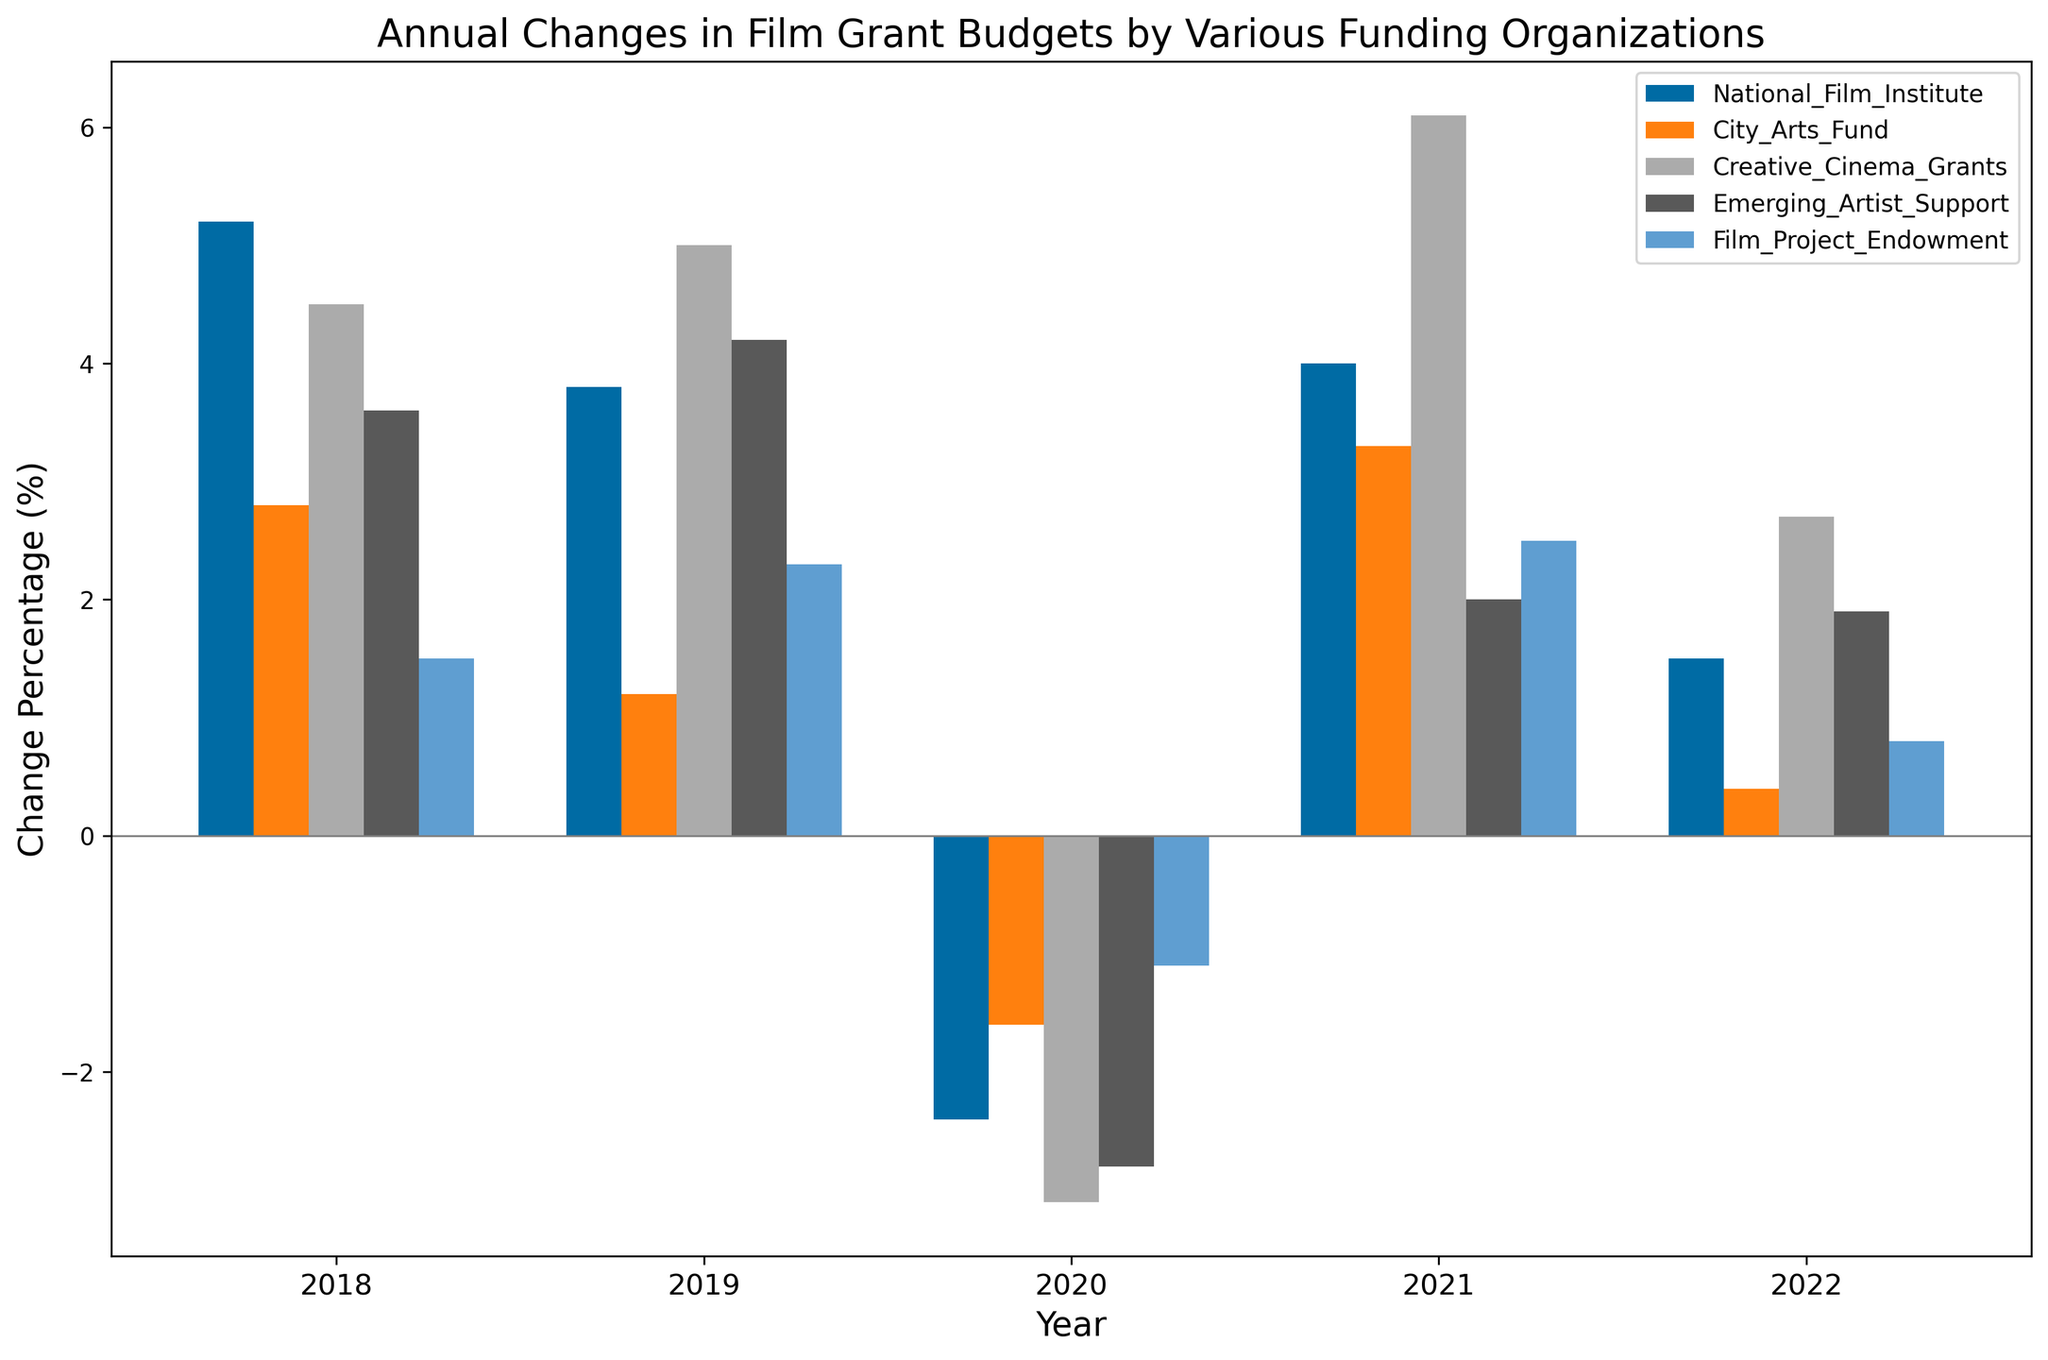What is the overall trend for the National Film Institute from 2018 to 2022? To find the overall trend for the National Film Institute, observe the height of the bars for each year from 2018 to 2022. The heights correspond to the change percentages. The trend involves identifying whether the changes are generally increasing or decreasing over the years. From the data, it is visible that the change is generally positive with a minor dip in 2020 (-2.4%). The overall trend appears to be positive.
Answer: Positive In which year did the Creative Cinema Grants experience the largest increase in their budget? Examine the bars representing Creative Cinema Grants and identify the one with the greatest positive height. The largest increase is evident in 2021, where the bar is the highest at 6.1%.
Answer: 2021 Compare the changes in budget for Emerging Artist Support in 2020 and 2022. Which year had a higher change in percentage? Locate the bars for Emerging Artist Support for the years 2020 and 2022. The 2020 bar shows a change of -2.8%, and the 2022 bar shows a change of 1.9%. 1.9% is higher than -2.8%, hence 2022 had a higher change.
Answer: 2022 What is the average change in budget for the City Arts Fund from 2018 to 2022? Identify the bars for the City Arts Fund from 2018 to 2022 and sum their change percentages: 2.8%, 1.2%, -1.6%, 3.3%, and 0.4%. Then, divide the total by the number of years (5). (2.8 + 1.2 - 1.6 + 3.3 + 0.4) / 5 = 1.22%.
Answer: 1.22% Which organization had the most consistent changes in their budgets over the years, and how can this be observed? Consistency can be observed by examining which organization has bars of nearly equal heights over the years. The Film Project Endowment shows relatively consistent bars with changes ranging between -1.1% and 2.5% from 2018 to 2022. This smaller range indicates consistency compared to wider fluctuations in other organizations.
Answer: Film Project Endowment Which year saw the most organizations experiencing a decrease in their budget, and which organizations were they? Identify the years where multiple bars fall below 0%. In 2020, the bars for National Film Institute (-2.4%), City Arts Fund (-1.6%), Creative Cinema Grants (-3.1%), and Emerging Artist Support (-2.8%) fall below 0%. Four organizations saw a decrease in 2020, making it the year with the most organizations experiencing a decrease.
Answer: 2020, National Film Institute, City Arts Fund, Creative Cinema Grants, Emerging Artist Support What is the difference in the budget change between the highest and lowest changes for Creative Cinema Grants across the given years? Locate the highest and lowest bars for Creative Cinema Grants. The highest is 6.1% in 2021, and the lowest is -3.1% in 2020. Calculate the difference by subtracting the lowest from the highest: 6.1% - (-3.1%) = 6.1% + 3.1% = 9.2%.
Answer: 9.2% How does the 2021 budget change for the National Film Institute compare to its 2020 budget change? Observe the bars for the National Film Institute for 2020 and 2021. The 2020 change is -2.4%, and the 2021 change is 4.0%. Comparing these values, 2021 saw an increase whereas 2020 saw a decrease. 4.0% is an increase from -2.4%.
Answer: 2021 had a higher increase 